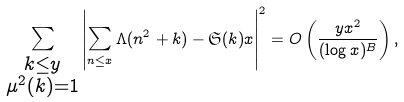Convert formula to latex. <formula><loc_0><loc_0><loc_500><loc_500>\sum _ { \substack { k \leq y \\ \mu ^ { 2 } ( k ) = 1 } } \left | \sum _ { n \leq x } \Lambda ( n ^ { 2 } + k ) - \mathfrak { S } ( k ) x \right | ^ { 2 } = O \left ( \frac { y x ^ { 2 } } { ( \log x ) ^ { B } } \right ) ,</formula> 